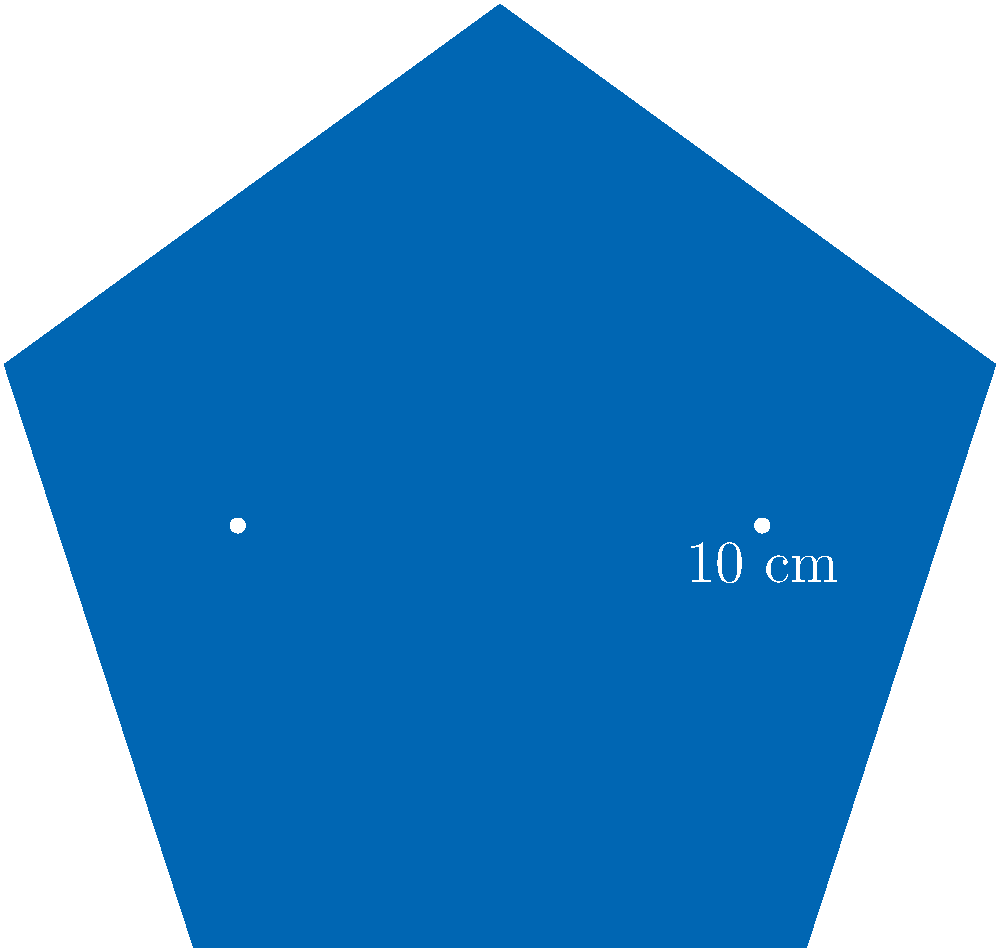A prestigious Wall Street law firm has designed a new pentagonal corporate logo with equal sides. If each side of the pentagon measures 10 cm, what is the perimeter of the logo? Additionally, calculate the area of the logo to the nearest square centimeter. To solve this problem, we'll approach it step-by-step:

1. Calculating the perimeter:
   - The logo is a regular pentagon with equal sides.
   - Each side measures 10 cm.
   - The perimeter is the sum of all sides.
   - Perimeter = 5 × 10 cm = 50 cm

2. Calculating the area:
   - For a regular pentagon, the area formula is:
     $$ A = \frac{1}{4} \sqrt{25 + 10\sqrt{5}} \times s^2 $$
     where $s$ is the length of a side.
   - Substituting $s = 10$ cm:
     $$ A = \frac{1}{4} \sqrt{25 + 10\sqrt{5}} \times 10^2 $$
   - Simplifying:
     $$ A = 25\sqrt{25 + 10\sqrt{5}} $$
   - Using a calculator:
     $A \approx 172.05$ cm²
   - Rounding to the nearest square centimeter:
     $A \approx 172$ cm²

Therefore, the perimeter of the logo is 50 cm, and its area is approximately 172 cm².
Answer: Perimeter: 50 cm; Area: 172 cm² 